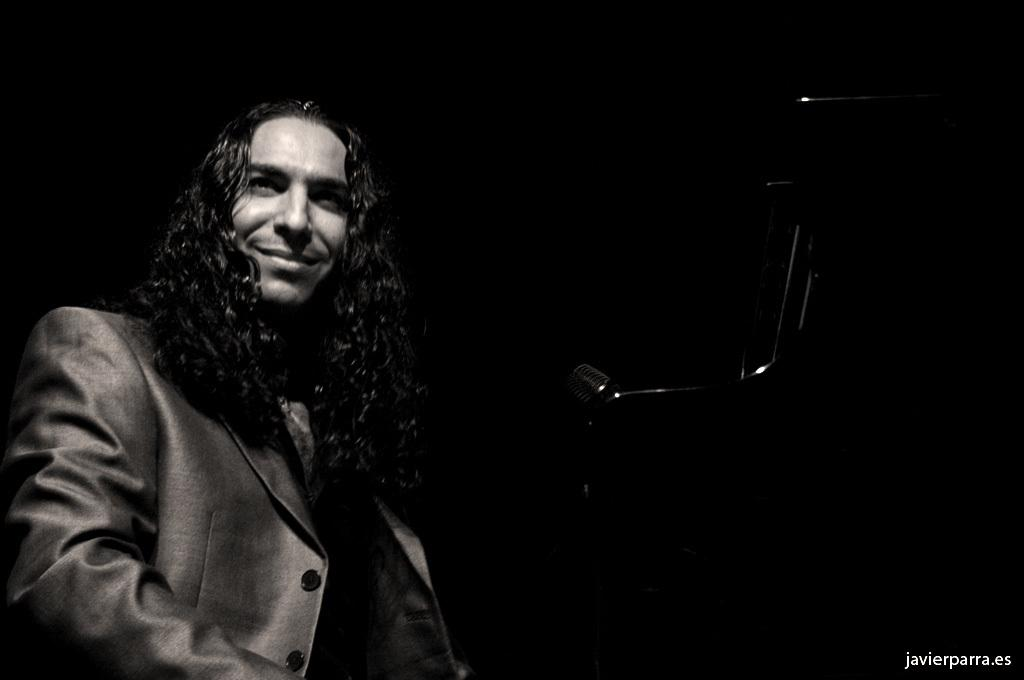What is the color scheme of the image? The image is black and white. Who is present in the image? There is a man in the image. What is the man's facial expression? The man is smiling. What object can be seen in the image related to speaking or performing? There is a microphone on a stand in the image. How does the man change the current in the image? There is no indication of the man changing any current in the image; the focus is on his smiling expression and the presence of a microphone on a stand. 